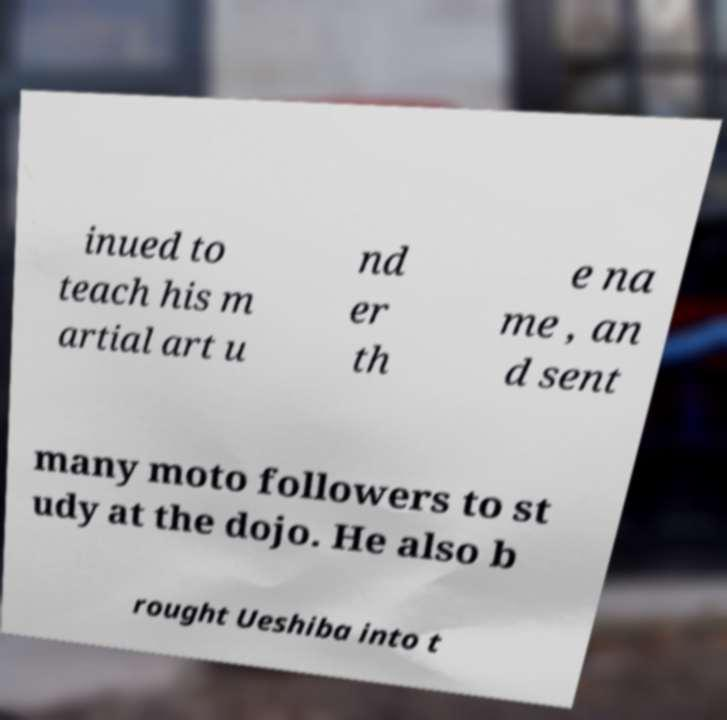What messages or text are displayed in this image? I need them in a readable, typed format. inued to teach his m artial art u nd er th e na me , an d sent many moto followers to st udy at the dojo. He also b rought Ueshiba into t 